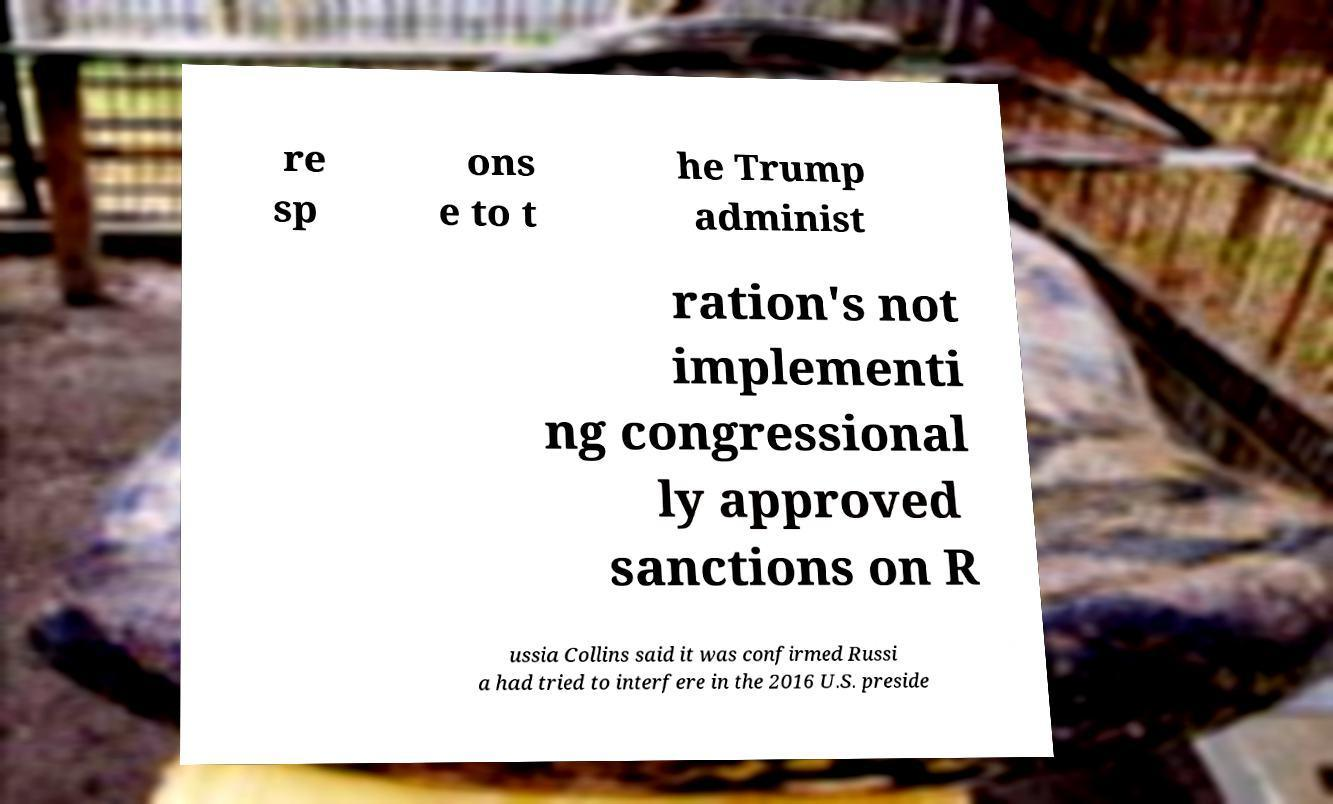Can you read and provide the text displayed in the image?This photo seems to have some interesting text. Can you extract and type it out for me? re sp ons e to t he Trump administ ration's not implementi ng congressional ly approved sanctions on R ussia Collins said it was confirmed Russi a had tried to interfere in the 2016 U.S. preside 